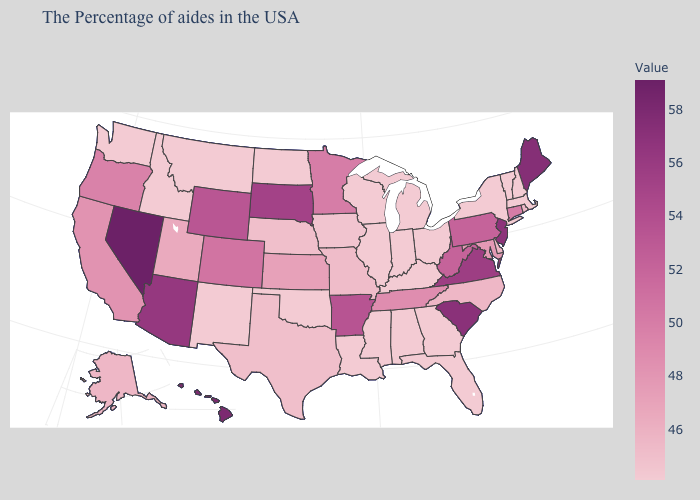Does Oregon have the lowest value in the West?
Write a very short answer. No. Among the states that border California , does Oregon have the lowest value?
Concise answer only. Yes. Does the map have missing data?
Write a very short answer. No. Which states hav the highest value in the South?
Write a very short answer. South Carolina. Does Kentucky have the highest value in the USA?
Short answer required. No. Does Florida have the highest value in the USA?
Quick response, please. No. Which states hav the highest value in the South?
Short answer required. South Carolina. Does Nevada have the highest value in the USA?
Write a very short answer. Yes. Which states hav the highest value in the West?
Be succinct. Nevada. 